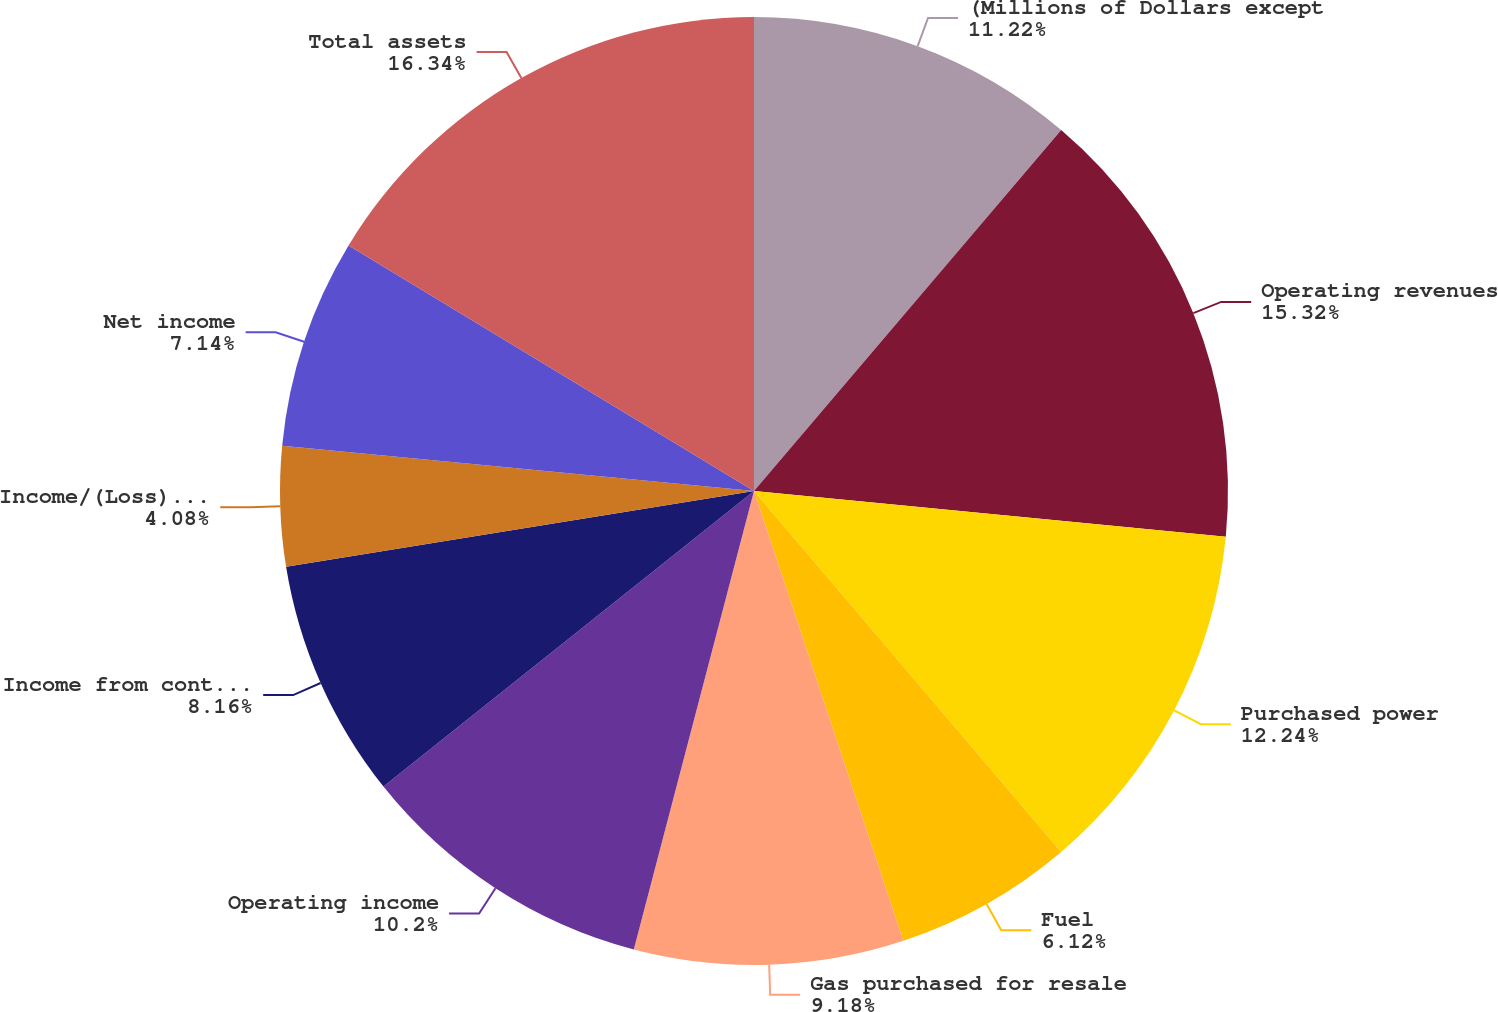Convert chart to OTSL. <chart><loc_0><loc_0><loc_500><loc_500><pie_chart><fcel>(Millions of Dollars except<fcel>Operating revenues<fcel>Purchased power<fcel>Fuel<fcel>Gas purchased for resale<fcel>Operating income<fcel>Income from continuing<fcel>Income/(Loss) from<fcel>Net income<fcel>Total assets<nl><fcel>11.22%<fcel>15.31%<fcel>12.24%<fcel>6.12%<fcel>9.18%<fcel>10.2%<fcel>8.16%<fcel>4.08%<fcel>7.14%<fcel>16.33%<nl></chart> 